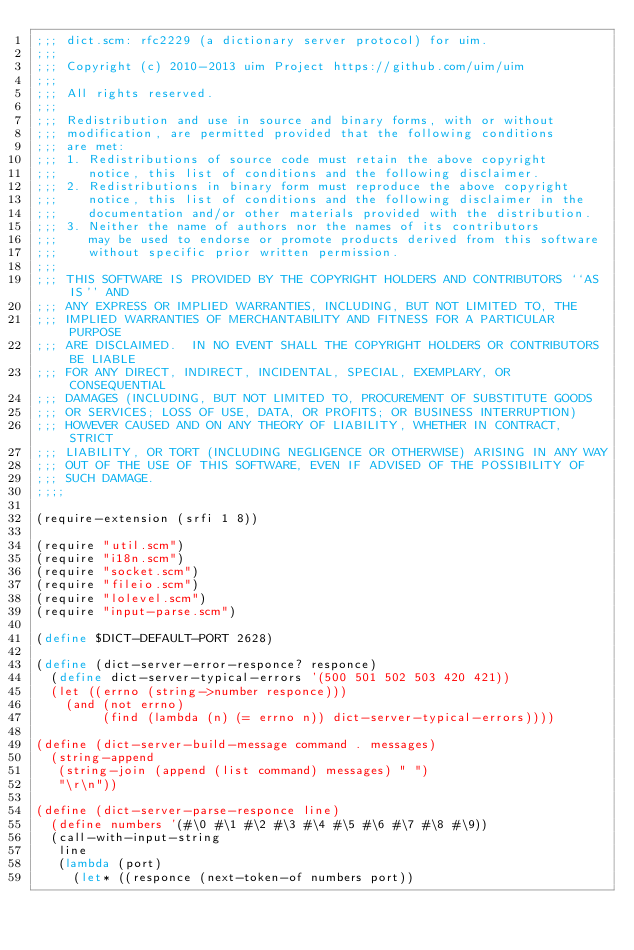<code> <loc_0><loc_0><loc_500><loc_500><_Scheme_>;;; dict.scm: rfc2229 (a dictionary server protocol) for uim.
;;;
;;; Copyright (c) 2010-2013 uim Project https://github.com/uim/uim
;;;
;;; All rights reserved.
;;;
;;; Redistribution and use in source and binary forms, with or without
;;; modification, are permitted provided that the following conditions
;;; are met:
;;; 1. Redistributions of source code must retain the above copyright
;;;    notice, this list of conditions and the following disclaimer.
;;; 2. Redistributions in binary form must reproduce the above copyright
;;;    notice, this list of conditions and the following disclaimer in the
;;;    documentation and/or other materials provided with the distribution.
;;; 3. Neither the name of authors nor the names of its contributors
;;;    may be used to endorse or promote products derived from this software
;;;    without specific prior written permission.
;;;
;;; THIS SOFTWARE IS PROVIDED BY THE COPYRIGHT HOLDERS AND CONTRIBUTORS ``AS IS'' AND
;;; ANY EXPRESS OR IMPLIED WARRANTIES, INCLUDING, BUT NOT LIMITED TO, THE
;;; IMPLIED WARRANTIES OF MERCHANTABILITY AND FITNESS FOR A PARTICULAR PURPOSE
;;; ARE DISCLAIMED.  IN NO EVENT SHALL THE COPYRIGHT HOLDERS OR CONTRIBUTORS BE LIABLE
;;; FOR ANY DIRECT, INDIRECT, INCIDENTAL, SPECIAL, EXEMPLARY, OR CONSEQUENTIAL
;;; DAMAGES (INCLUDING, BUT NOT LIMITED TO, PROCUREMENT OF SUBSTITUTE GOODS
;;; OR SERVICES; LOSS OF USE, DATA, OR PROFITS; OR BUSINESS INTERRUPTION)
;;; HOWEVER CAUSED AND ON ANY THEORY OF LIABILITY, WHETHER IN CONTRACT, STRICT
;;; LIABILITY, OR TORT (INCLUDING NEGLIGENCE OR OTHERWISE) ARISING IN ANY WAY
;;; OUT OF THE USE OF THIS SOFTWARE, EVEN IF ADVISED OF THE POSSIBILITY OF
;;; SUCH DAMAGE.
;;;;

(require-extension (srfi 1 8))

(require "util.scm")
(require "i18n.scm")
(require "socket.scm")
(require "fileio.scm")
(require "lolevel.scm")
(require "input-parse.scm")

(define $DICT-DEFAULT-PORT 2628)

(define (dict-server-error-responce? responce)
  (define dict-server-typical-errors '(500 501 502 503 420 421))
  (let ((errno (string->number responce)))
    (and (not errno)
         (find (lambda (n) (= errno n)) dict-server-typical-errors))))

(define (dict-server-build-message command . messages)
  (string-append
   (string-join (append (list command) messages) " ")
   "\r\n"))

(define (dict-server-parse-responce line)
  (define numbers '(#\0 #\1 #\2 #\3 #\4 #\5 #\6 #\7 #\8 #\9))
  (call-with-input-string
   line
   (lambda (port)
     (let* ((responce (next-token-of numbers port))</code> 